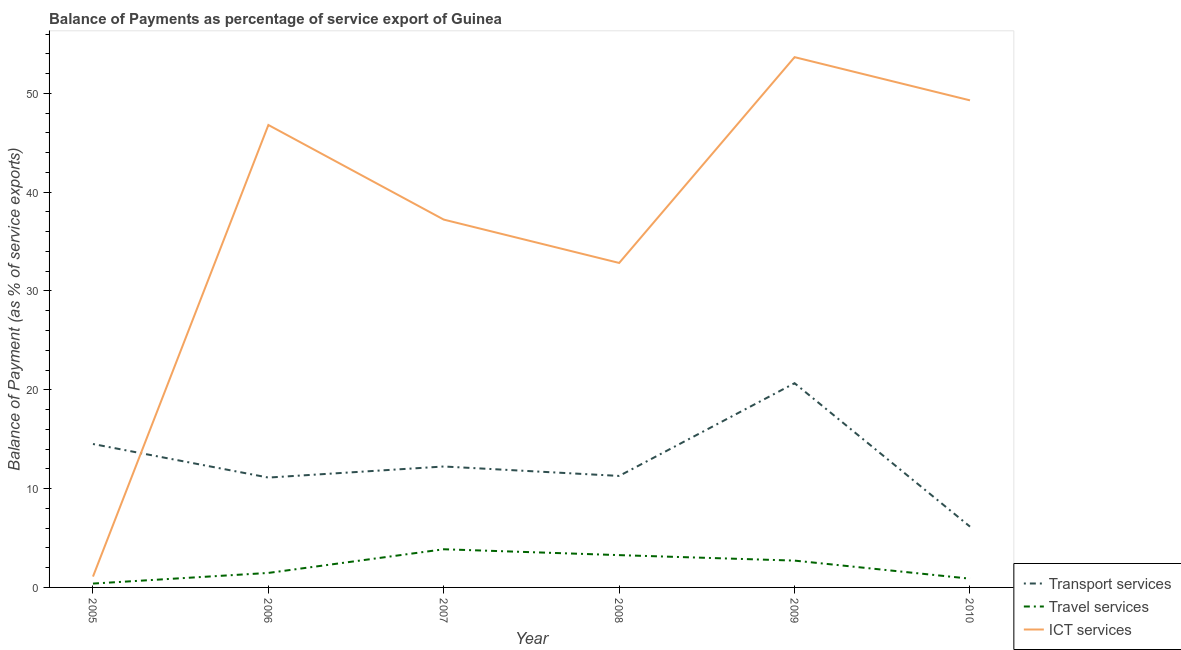How many different coloured lines are there?
Keep it short and to the point. 3. What is the balance of payment of transport services in 2005?
Give a very brief answer. 14.51. Across all years, what is the maximum balance of payment of transport services?
Keep it short and to the point. 20.67. Across all years, what is the minimum balance of payment of ict services?
Your response must be concise. 1.1. In which year was the balance of payment of travel services minimum?
Your response must be concise. 2005. What is the total balance of payment of travel services in the graph?
Give a very brief answer. 12.59. What is the difference between the balance of payment of ict services in 2005 and that in 2006?
Your answer should be compact. -45.7. What is the difference between the balance of payment of ict services in 2008 and the balance of payment of travel services in 2005?
Offer a terse response. 32.44. What is the average balance of payment of ict services per year?
Give a very brief answer. 36.82. In the year 2007, what is the difference between the balance of payment of travel services and balance of payment of ict services?
Offer a terse response. -33.36. What is the ratio of the balance of payment of transport services in 2006 to that in 2007?
Offer a terse response. 0.91. Is the balance of payment of travel services in 2005 less than that in 2010?
Your answer should be very brief. Yes. What is the difference between the highest and the second highest balance of payment of transport services?
Your response must be concise. 6.15. What is the difference between the highest and the lowest balance of payment of travel services?
Your answer should be compact. 3.47. Does the balance of payment of transport services monotonically increase over the years?
Keep it short and to the point. No. Is the balance of payment of ict services strictly greater than the balance of payment of transport services over the years?
Your answer should be compact. No. Is the balance of payment of ict services strictly less than the balance of payment of travel services over the years?
Your answer should be compact. No. How many lines are there?
Keep it short and to the point. 3. What is the difference between two consecutive major ticks on the Y-axis?
Provide a short and direct response. 10. Does the graph contain any zero values?
Offer a very short reply. No. Does the graph contain grids?
Offer a very short reply. No. Where does the legend appear in the graph?
Your answer should be very brief. Bottom right. How many legend labels are there?
Your answer should be very brief. 3. What is the title of the graph?
Your response must be concise. Balance of Payments as percentage of service export of Guinea. Does "Financial account" appear as one of the legend labels in the graph?
Make the answer very short. No. What is the label or title of the Y-axis?
Make the answer very short. Balance of Payment (as % of service exports). What is the Balance of Payment (as % of service exports) of Transport services in 2005?
Provide a succinct answer. 14.51. What is the Balance of Payment (as % of service exports) of Travel services in 2005?
Keep it short and to the point. 0.39. What is the Balance of Payment (as % of service exports) in ICT services in 2005?
Ensure brevity in your answer.  1.1. What is the Balance of Payment (as % of service exports) in Transport services in 2006?
Give a very brief answer. 11.12. What is the Balance of Payment (as % of service exports) in Travel services in 2006?
Offer a terse response. 1.47. What is the Balance of Payment (as % of service exports) in ICT services in 2006?
Provide a short and direct response. 46.8. What is the Balance of Payment (as % of service exports) in Transport services in 2007?
Offer a terse response. 12.24. What is the Balance of Payment (as % of service exports) of Travel services in 2007?
Offer a terse response. 3.86. What is the Balance of Payment (as % of service exports) in ICT services in 2007?
Make the answer very short. 37.22. What is the Balance of Payment (as % of service exports) in Transport services in 2008?
Provide a short and direct response. 11.28. What is the Balance of Payment (as % of service exports) of Travel services in 2008?
Your response must be concise. 3.27. What is the Balance of Payment (as % of service exports) in ICT services in 2008?
Provide a succinct answer. 32.83. What is the Balance of Payment (as % of service exports) in Transport services in 2009?
Ensure brevity in your answer.  20.67. What is the Balance of Payment (as % of service exports) of Travel services in 2009?
Your response must be concise. 2.71. What is the Balance of Payment (as % of service exports) of ICT services in 2009?
Provide a succinct answer. 53.66. What is the Balance of Payment (as % of service exports) of Transport services in 2010?
Your response must be concise. 6.15. What is the Balance of Payment (as % of service exports) of Travel services in 2010?
Offer a terse response. 0.89. What is the Balance of Payment (as % of service exports) in ICT services in 2010?
Give a very brief answer. 49.29. Across all years, what is the maximum Balance of Payment (as % of service exports) in Transport services?
Provide a short and direct response. 20.67. Across all years, what is the maximum Balance of Payment (as % of service exports) in Travel services?
Your answer should be very brief. 3.86. Across all years, what is the maximum Balance of Payment (as % of service exports) in ICT services?
Give a very brief answer. 53.66. Across all years, what is the minimum Balance of Payment (as % of service exports) in Transport services?
Offer a very short reply. 6.15. Across all years, what is the minimum Balance of Payment (as % of service exports) in Travel services?
Provide a short and direct response. 0.39. Across all years, what is the minimum Balance of Payment (as % of service exports) in ICT services?
Make the answer very short. 1.1. What is the total Balance of Payment (as % of service exports) in Transport services in the graph?
Provide a succinct answer. 75.97. What is the total Balance of Payment (as % of service exports) of Travel services in the graph?
Offer a terse response. 12.59. What is the total Balance of Payment (as % of service exports) in ICT services in the graph?
Offer a terse response. 220.9. What is the difference between the Balance of Payment (as % of service exports) of Transport services in 2005 and that in 2006?
Offer a terse response. 3.4. What is the difference between the Balance of Payment (as % of service exports) in Travel services in 2005 and that in 2006?
Your answer should be very brief. -1.08. What is the difference between the Balance of Payment (as % of service exports) of ICT services in 2005 and that in 2006?
Provide a succinct answer. -45.7. What is the difference between the Balance of Payment (as % of service exports) in Transport services in 2005 and that in 2007?
Offer a terse response. 2.27. What is the difference between the Balance of Payment (as % of service exports) of Travel services in 2005 and that in 2007?
Your response must be concise. -3.47. What is the difference between the Balance of Payment (as % of service exports) in ICT services in 2005 and that in 2007?
Provide a succinct answer. -36.12. What is the difference between the Balance of Payment (as % of service exports) in Transport services in 2005 and that in 2008?
Give a very brief answer. 3.23. What is the difference between the Balance of Payment (as % of service exports) in Travel services in 2005 and that in 2008?
Offer a very short reply. -2.88. What is the difference between the Balance of Payment (as % of service exports) in ICT services in 2005 and that in 2008?
Provide a succinct answer. -31.74. What is the difference between the Balance of Payment (as % of service exports) of Transport services in 2005 and that in 2009?
Your answer should be compact. -6.15. What is the difference between the Balance of Payment (as % of service exports) of Travel services in 2005 and that in 2009?
Offer a very short reply. -2.32. What is the difference between the Balance of Payment (as % of service exports) in ICT services in 2005 and that in 2009?
Make the answer very short. -52.56. What is the difference between the Balance of Payment (as % of service exports) in Transport services in 2005 and that in 2010?
Give a very brief answer. 8.36. What is the difference between the Balance of Payment (as % of service exports) of Travel services in 2005 and that in 2010?
Your answer should be compact. -0.5. What is the difference between the Balance of Payment (as % of service exports) of ICT services in 2005 and that in 2010?
Your answer should be very brief. -48.19. What is the difference between the Balance of Payment (as % of service exports) in Transport services in 2006 and that in 2007?
Your response must be concise. -1.12. What is the difference between the Balance of Payment (as % of service exports) in Travel services in 2006 and that in 2007?
Offer a very short reply. -2.39. What is the difference between the Balance of Payment (as % of service exports) of ICT services in 2006 and that in 2007?
Your response must be concise. 9.58. What is the difference between the Balance of Payment (as % of service exports) of Transport services in 2006 and that in 2008?
Offer a very short reply. -0.17. What is the difference between the Balance of Payment (as % of service exports) in Travel services in 2006 and that in 2008?
Your response must be concise. -1.8. What is the difference between the Balance of Payment (as % of service exports) in ICT services in 2006 and that in 2008?
Provide a succinct answer. 13.96. What is the difference between the Balance of Payment (as % of service exports) in Transport services in 2006 and that in 2009?
Give a very brief answer. -9.55. What is the difference between the Balance of Payment (as % of service exports) of Travel services in 2006 and that in 2009?
Your response must be concise. -1.25. What is the difference between the Balance of Payment (as % of service exports) of ICT services in 2006 and that in 2009?
Your answer should be very brief. -6.86. What is the difference between the Balance of Payment (as % of service exports) of Transport services in 2006 and that in 2010?
Your answer should be compact. 4.96. What is the difference between the Balance of Payment (as % of service exports) of Travel services in 2006 and that in 2010?
Provide a succinct answer. 0.58. What is the difference between the Balance of Payment (as % of service exports) of ICT services in 2006 and that in 2010?
Your answer should be compact. -2.49. What is the difference between the Balance of Payment (as % of service exports) of Transport services in 2007 and that in 2008?
Provide a short and direct response. 0.96. What is the difference between the Balance of Payment (as % of service exports) of Travel services in 2007 and that in 2008?
Your answer should be compact. 0.59. What is the difference between the Balance of Payment (as % of service exports) in ICT services in 2007 and that in 2008?
Your answer should be very brief. 4.39. What is the difference between the Balance of Payment (as % of service exports) of Transport services in 2007 and that in 2009?
Provide a short and direct response. -8.43. What is the difference between the Balance of Payment (as % of service exports) of Travel services in 2007 and that in 2009?
Provide a short and direct response. 1.15. What is the difference between the Balance of Payment (as % of service exports) of ICT services in 2007 and that in 2009?
Ensure brevity in your answer.  -16.44. What is the difference between the Balance of Payment (as % of service exports) in Transport services in 2007 and that in 2010?
Make the answer very short. 6.09. What is the difference between the Balance of Payment (as % of service exports) in Travel services in 2007 and that in 2010?
Keep it short and to the point. 2.98. What is the difference between the Balance of Payment (as % of service exports) in ICT services in 2007 and that in 2010?
Keep it short and to the point. -12.07. What is the difference between the Balance of Payment (as % of service exports) in Transport services in 2008 and that in 2009?
Give a very brief answer. -9.38. What is the difference between the Balance of Payment (as % of service exports) of Travel services in 2008 and that in 2009?
Make the answer very short. 0.55. What is the difference between the Balance of Payment (as % of service exports) of ICT services in 2008 and that in 2009?
Your answer should be compact. -20.83. What is the difference between the Balance of Payment (as % of service exports) in Transport services in 2008 and that in 2010?
Your answer should be very brief. 5.13. What is the difference between the Balance of Payment (as % of service exports) in Travel services in 2008 and that in 2010?
Offer a terse response. 2.38. What is the difference between the Balance of Payment (as % of service exports) of ICT services in 2008 and that in 2010?
Provide a short and direct response. -16.45. What is the difference between the Balance of Payment (as % of service exports) of Transport services in 2009 and that in 2010?
Your response must be concise. 14.51. What is the difference between the Balance of Payment (as % of service exports) in Travel services in 2009 and that in 2010?
Ensure brevity in your answer.  1.83. What is the difference between the Balance of Payment (as % of service exports) in ICT services in 2009 and that in 2010?
Provide a short and direct response. 4.37. What is the difference between the Balance of Payment (as % of service exports) in Transport services in 2005 and the Balance of Payment (as % of service exports) in Travel services in 2006?
Provide a short and direct response. 13.05. What is the difference between the Balance of Payment (as % of service exports) in Transport services in 2005 and the Balance of Payment (as % of service exports) in ICT services in 2006?
Give a very brief answer. -32.28. What is the difference between the Balance of Payment (as % of service exports) in Travel services in 2005 and the Balance of Payment (as % of service exports) in ICT services in 2006?
Ensure brevity in your answer.  -46.41. What is the difference between the Balance of Payment (as % of service exports) of Transport services in 2005 and the Balance of Payment (as % of service exports) of Travel services in 2007?
Ensure brevity in your answer.  10.65. What is the difference between the Balance of Payment (as % of service exports) of Transport services in 2005 and the Balance of Payment (as % of service exports) of ICT services in 2007?
Provide a succinct answer. -22.71. What is the difference between the Balance of Payment (as % of service exports) of Travel services in 2005 and the Balance of Payment (as % of service exports) of ICT services in 2007?
Provide a short and direct response. -36.83. What is the difference between the Balance of Payment (as % of service exports) in Transport services in 2005 and the Balance of Payment (as % of service exports) in Travel services in 2008?
Make the answer very short. 11.24. What is the difference between the Balance of Payment (as % of service exports) in Transport services in 2005 and the Balance of Payment (as % of service exports) in ICT services in 2008?
Your response must be concise. -18.32. What is the difference between the Balance of Payment (as % of service exports) of Travel services in 2005 and the Balance of Payment (as % of service exports) of ICT services in 2008?
Offer a very short reply. -32.44. What is the difference between the Balance of Payment (as % of service exports) of Transport services in 2005 and the Balance of Payment (as % of service exports) of Travel services in 2009?
Provide a short and direct response. 11.8. What is the difference between the Balance of Payment (as % of service exports) of Transport services in 2005 and the Balance of Payment (as % of service exports) of ICT services in 2009?
Offer a very short reply. -39.15. What is the difference between the Balance of Payment (as % of service exports) of Travel services in 2005 and the Balance of Payment (as % of service exports) of ICT services in 2009?
Your response must be concise. -53.27. What is the difference between the Balance of Payment (as % of service exports) of Transport services in 2005 and the Balance of Payment (as % of service exports) of Travel services in 2010?
Keep it short and to the point. 13.63. What is the difference between the Balance of Payment (as % of service exports) of Transport services in 2005 and the Balance of Payment (as % of service exports) of ICT services in 2010?
Provide a short and direct response. -34.78. What is the difference between the Balance of Payment (as % of service exports) in Travel services in 2005 and the Balance of Payment (as % of service exports) in ICT services in 2010?
Provide a succinct answer. -48.9. What is the difference between the Balance of Payment (as % of service exports) in Transport services in 2006 and the Balance of Payment (as % of service exports) in Travel services in 2007?
Offer a terse response. 7.25. What is the difference between the Balance of Payment (as % of service exports) in Transport services in 2006 and the Balance of Payment (as % of service exports) in ICT services in 2007?
Offer a terse response. -26.1. What is the difference between the Balance of Payment (as % of service exports) in Travel services in 2006 and the Balance of Payment (as % of service exports) in ICT services in 2007?
Your answer should be very brief. -35.75. What is the difference between the Balance of Payment (as % of service exports) in Transport services in 2006 and the Balance of Payment (as % of service exports) in Travel services in 2008?
Offer a very short reply. 7.85. What is the difference between the Balance of Payment (as % of service exports) of Transport services in 2006 and the Balance of Payment (as % of service exports) of ICT services in 2008?
Your response must be concise. -21.72. What is the difference between the Balance of Payment (as % of service exports) of Travel services in 2006 and the Balance of Payment (as % of service exports) of ICT services in 2008?
Your response must be concise. -31.37. What is the difference between the Balance of Payment (as % of service exports) in Transport services in 2006 and the Balance of Payment (as % of service exports) in Travel services in 2009?
Your response must be concise. 8.4. What is the difference between the Balance of Payment (as % of service exports) in Transport services in 2006 and the Balance of Payment (as % of service exports) in ICT services in 2009?
Keep it short and to the point. -42.54. What is the difference between the Balance of Payment (as % of service exports) of Travel services in 2006 and the Balance of Payment (as % of service exports) of ICT services in 2009?
Your response must be concise. -52.19. What is the difference between the Balance of Payment (as % of service exports) in Transport services in 2006 and the Balance of Payment (as % of service exports) in Travel services in 2010?
Keep it short and to the point. 10.23. What is the difference between the Balance of Payment (as % of service exports) in Transport services in 2006 and the Balance of Payment (as % of service exports) in ICT services in 2010?
Offer a very short reply. -38.17. What is the difference between the Balance of Payment (as % of service exports) of Travel services in 2006 and the Balance of Payment (as % of service exports) of ICT services in 2010?
Offer a very short reply. -47.82. What is the difference between the Balance of Payment (as % of service exports) of Transport services in 2007 and the Balance of Payment (as % of service exports) of Travel services in 2008?
Keep it short and to the point. 8.97. What is the difference between the Balance of Payment (as % of service exports) of Transport services in 2007 and the Balance of Payment (as % of service exports) of ICT services in 2008?
Make the answer very short. -20.6. What is the difference between the Balance of Payment (as % of service exports) of Travel services in 2007 and the Balance of Payment (as % of service exports) of ICT services in 2008?
Offer a terse response. -28.97. What is the difference between the Balance of Payment (as % of service exports) of Transport services in 2007 and the Balance of Payment (as % of service exports) of Travel services in 2009?
Offer a very short reply. 9.52. What is the difference between the Balance of Payment (as % of service exports) in Transport services in 2007 and the Balance of Payment (as % of service exports) in ICT services in 2009?
Your answer should be very brief. -41.42. What is the difference between the Balance of Payment (as % of service exports) of Travel services in 2007 and the Balance of Payment (as % of service exports) of ICT services in 2009?
Your response must be concise. -49.8. What is the difference between the Balance of Payment (as % of service exports) in Transport services in 2007 and the Balance of Payment (as % of service exports) in Travel services in 2010?
Your answer should be very brief. 11.35. What is the difference between the Balance of Payment (as % of service exports) in Transport services in 2007 and the Balance of Payment (as % of service exports) in ICT services in 2010?
Offer a terse response. -37.05. What is the difference between the Balance of Payment (as % of service exports) of Travel services in 2007 and the Balance of Payment (as % of service exports) of ICT services in 2010?
Make the answer very short. -45.43. What is the difference between the Balance of Payment (as % of service exports) of Transport services in 2008 and the Balance of Payment (as % of service exports) of Travel services in 2009?
Offer a very short reply. 8.57. What is the difference between the Balance of Payment (as % of service exports) of Transport services in 2008 and the Balance of Payment (as % of service exports) of ICT services in 2009?
Give a very brief answer. -42.38. What is the difference between the Balance of Payment (as % of service exports) in Travel services in 2008 and the Balance of Payment (as % of service exports) in ICT services in 2009?
Ensure brevity in your answer.  -50.39. What is the difference between the Balance of Payment (as % of service exports) of Transport services in 2008 and the Balance of Payment (as % of service exports) of Travel services in 2010?
Your answer should be very brief. 10.4. What is the difference between the Balance of Payment (as % of service exports) of Transport services in 2008 and the Balance of Payment (as % of service exports) of ICT services in 2010?
Keep it short and to the point. -38.01. What is the difference between the Balance of Payment (as % of service exports) of Travel services in 2008 and the Balance of Payment (as % of service exports) of ICT services in 2010?
Offer a terse response. -46.02. What is the difference between the Balance of Payment (as % of service exports) in Transport services in 2009 and the Balance of Payment (as % of service exports) in Travel services in 2010?
Make the answer very short. 19.78. What is the difference between the Balance of Payment (as % of service exports) of Transport services in 2009 and the Balance of Payment (as % of service exports) of ICT services in 2010?
Your response must be concise. -28.62. What is the difference between the Balance of Payment (as % of service exports) in Travel services in 2009 and the Balance of Payment (as % of service exports) in ICT services in 2010?
Keep it short and to the point. -46.58. What is the average Balance of Payment (as % of service exports) of Transport services per year?
Make the answer very short. 12.66. What is the average Balance of Payment (as % of service exports) in Travel services per year?
Keep it short and to the point. 2.1. What is the average Balance of Payment (as % of service exports) in ICT services per year?
Your answer should be compact. 36.82. In the year 2005, what is the difference between the Balance of Payment (as % of service exports) of Transport services and Balance of Payment (as % of service exports) of Travel services?
Provide a short and direct response. 14.12. In the year 2005, what is the difference between the Balance of Payment (as % of service exports) in Transport services and Balance of Payment (as % of service exports) in ICT services?
Ensure brevity in your answer.  13.42. In the year 2005, what is the difference between the Balance of Payment (as % of service exports) of Travel services and Balance of Payment (as % of service exports) of ICT services?
Provide a succinct answer. -0.71. In the year 2006, what is the difference between the Balance of Payment (as % of service exports) in Transport services and Balance of Payment (as % of service exports) in Travel services?
Your answer should be compact. 9.65. In the year 2006, what is the difference between the Balance of Payment (as % of service exports) in Transport services and Balance of Payment (as % of service exports) in ICT services?
Offer a terse response. -35.68. In the year 2006, what is the difference between the Balance of Payment (as % of service exports) in Travel services and Balance of Payment (as % of service exports) in ICT services?
Provide a short and direct response. -45.33. In the year 2007, what is the difference between the Balance of Payment (as % of service exports) in Transport services and Balance of Payment (as % of service exports) in Travel services?
Provide a short and direct response. 8.38. In the year 2007, what is the difference between the Balance of Payment (as % of service exports) in Transport services and Balance of Payment (as % of service exports) in ICT services?
Offer a very short reply. -24.98. In the year 2007, what is the difference between the Balance of Payment (as % of service exports) in Travel services and Balance of Payment (as % of service exports) in ICT services?
Offer a very short reply. -33.36. In the year 2008, what is the difference between the Balance of Payment (as % of service exports) in Transport services and Balance of Payment (as % of service exports) in Travel services?
Provide a short and direct response. 8.01. In the year 2008, what is the difference between the Balance of Payment (as % of service exports) in Transport services and Balance of Payment (as % of service exports) in ICT services?
Your answer should be compact. -21.55. In the year 2008, what is the difference between the Balance of Payment (as % of service exports) in Travel services and Balance of Payment (as % of service exports) in ICT services?
Ensure brevity in your answer.  -29.57. In the year 2009, what is the difference between the Balance of Payment (as % of service exports) of Transport services and Balance of Payment (as % of service exports) of Travel services?
Offer a very short reply. 17.95. In the year 2009, what is the difference between the Balance of Payment (as % of service exports) of Transport services and Balance of Payment (as % of service exports) of ICT services?
Give a very brief answer. -32.99. In the year 2009, what is the difference between the Balance of Payment (as % of service exports) of Travel services and Balance of Payment (as % of service exports) of ICT services?
Make the answer very short. -50.95. In the year 2010, what is the difference between the Balance of Payment (as % of service exports) of Transport services and Balance of Payment (as % of service exports) of Travel services?
Ensure brevity in your answer.  5.27. In the year 2010, what is the difference between the Balance of Payment (as % of service exports) of Transport services and Balance of Payment (as % of service exports) of ICT services?
Provide a succinct answer. -43.14. In the year 2010, what is the difference between the Balance of Payment (as % of service exports) in Travel services and Balance of Payment (as % of service exports) in ICT services?
Your response must be concise. -48.4. What is the ratio of the Balance of Payment (as % of service exports) of Transport services in 2005 to that in 2006?
Offer a very short reply. 1.31. What is the ratio of the Balance of Payment (as % of service exports) in Travel services in 2005 to that in 2006?
Provide a succinct answer. 0.27. What is the ratio of the Balance of Payment (as % of service exports) of ICT services in 2005 to that in 2006?
Your answer should be very brief. 0.02. What is the ratio of the Balance of Payment (as % of service exports) of Transport services in 2005 to that in 2007?
Give a very brief answer. 1.19. What is the ratio of the Balance of Payment (as % of service exports) of Travel services in 2005 to that in 2007?
Your answer should be very brief. 0.1. What is the ratio of the Balance of Payment (as % of service exports) in ICT services in 2005 to that in 2007?
Provide a short and direct response. 0.03. What is the ratio of the Balance of Payment (as % of service exports) of Transport services in 2005 to that in 2008?
Provide a short and direct response. 1.29. What is the ratio of the Balance of Payment (as % of service exports) in Travel services in 2005 to that in 2008?
Your answer should be very brief. 0.12. What is the ratio of the Balance of Payment (as % of service exports) in ICT services in 2005 to that in 2008?
Give a very brief answer. 0.03. What is the ratio of the Balance of Payment (as % of service exports) in Transport services in 2005 to that in 2009?
Provide a succinct answer. 0.7. What is the ratio of the Balance of Payment (as % of service exports) of Travel services in 2005 to that in 2009?
Offer a terse response. 0.14. What is the ratio of the Balance of Payment (as % of service exports) of ICT services in 2005 to that in 2009?
Make the answer very short. 0.02. What is the ratio of the Balance of Payment (as % of service exports) of Transport services in 2005 to that in 2010?
Offer a very short reply. 2.36. What is the ratio of the Balance of Payment (as % of service exports) of Travel services in 2005 to that in 2010?
Offer a very short reply. 0.44. What is the ratio of the Balance of Payment (as % of service exports) of ICT services in 2005 to that in 2010?
Your response must be concise. 0.02. What is the ratio of the Balance of Payment (as % of service exports) of Transport services in 2006 to that in 2007?
Offer a very short reply. 0.91. What is the ratio of the Balance of Payment (as % of service exports) in Travel services in 2006 to that in 2007?
Provide a succinct answer. 0.38. What is the ratio of the Balance of Payment (as % of service exports) in ICT services in 2006 to that in 2007?
Keep it short and to the point. 1.26. What is the ratio of the Balance of Payment (as % of service exports) in Transport services in 2006 to that in 2008?
Offer a terse response. 0.99. What is the ratio of the Balance of Payment (as % of service exports) of Travel services in 2006 to that in 2008?
Provide a short and direct response. 0.45. What is the ratio of the Balance of Payment (as % of service exports) in ICT services in 2006 to that in 2008?
Keep it short and to the point. 1.43. What is the ratio of the Balance of Payment (as % of service exports) of Transport services in 2006 to that in 2009?
Ensure brevity in your answer.  0.54. What is the ratio of the Balance of Payment (as % of service exports) in Travel services in 2006 to that in 2009?
Your response must be concise. 0.54. What is the ratio of the Balance of Payment (as % of service exports) of ICT services in 2006 to that in 2009?
Ensure brevity in your answer.  0.87. What is the ratio of the Balance of Payment (as % of service exports) of Transport services in 2006 to that in 2010?
Provide a short and direct response. 1.81. What is the ratio of the Balance of Payment (as % of service exports) of Travel services in 2006 to that in 2010?
Offer a very short reply. 1.66. What is the ratio of the Balance of Payment (as % of service exports) of ICT services in 2006 to that in 2010?
Offer a terse response. 0.95. What is the ratio of the Balance of Payment (as % of service exports) in Transport services in 2007 to that in 2008?
Your answer should be compact. 1.08. What is the ratio of the Balance of Payment (as % of service exports) of Travel services in 2007 to that in 2008?
Your answer should be very brief. 1.18. What is the ratio of the Balance of Payment (as % of service exports) of ICT services in 2007 to that in 2008?
Offer a very short reply. 1.13. What is the ratio of the Balance of Payment (as % of service exports) of Transport services in 2007 to that in 2009?
Give a very brief answer. 0.59. What is the ratio of the Balance of Payment (as % of service exports) in Travel services in 2007 to that in 2009?
Your response must be concise. 1.42. What is the ratio of the Balance of Payment (as % of service exports) in ICT services in 2007 to that in 2009?
Your answer should be compact. 0.69. What is the ratio of the Balance of Payment (as % of service exports) in Transport services in 2007 to that in 2010?
Keep it short and to the point. 1.99. What is the ratio of the Balance of Payment (as % of service exports) in Travel services in 2007 to that in 2010?
Your response must be concise. 4.36. What is the ratio of the Balance of Payment (as % of service exports) in ICT services in 2007 to that in 2010?
Offer a terse response. 0.76. What is the ratio of the Balance of Payment (as % of service exports) of Transport services in 2008 to that in 2009?
Make the answer very short. 0.55. What is the ratio of the Balance of Payment (as % of service exports) of Travel services in 2008 to that in 2009?
Your response must be concise. 1.2. What is the ratio of the Balance of Payment (as % of service exports) of ICT services in 2008 to that in 2009?
Offer a very short reply. 0.61. What is the ratio of the Balance of Payment (as % of service exports) in Transport services in 2008 to that in 2010?
Keep it short and to the point. 1.83. What is the ratio of the Balance of Payment (as % of service exports) of Travel services in 2008 to that in 2010?
Ensure brevity in your answer.  3.69. What is the ratio of the Balance of Payment (as % of service exports) in ICT services in 2008 to that in 2010?
Provide a short and direct response. 0.67. What is the ratio of the Balance of Payment (as % of service exports) in Transport services in 2009 to that in 2010?
Your response must be concise. 3.36. What is the ratio of the Balance of Payment (as % of service exports) in Travel services in 2009 to that in 2010?
Make the answer very short. 3.06. What is the ratio of the Balance of Payment (as % of service exports) in ICT services in 2009 to that in 2010?
Provide a short and direct response. 1.09. What is the difference between the highest and the second highest Balance of Payment (as % of service exports) in Transport services?
Your answer should be compact. 6.15. What is the difference between the highest and the second highest Balance of Payment (as % of service exports) of Travel services?
Make the answer very short. 0.59. What is the difference between the highest and the second highest Balance of Payment (as % of service exports) in ICT services?
Provide a short and direct response. 4.37. What is the difference between the highest and the lowest Balance of Payment (as % of service exports) in Transport services?
Your answer should be very brief. 14.51. What is the difference between the highest and the lowest Balance of Payment (as % of service exports) of Travel services?
Offer a terse response. 3.47. What is the difference between the highest and the lowest Balance of Payment (as % of service exports) in ICT services?
Your answer should be very brief. 52.56. 